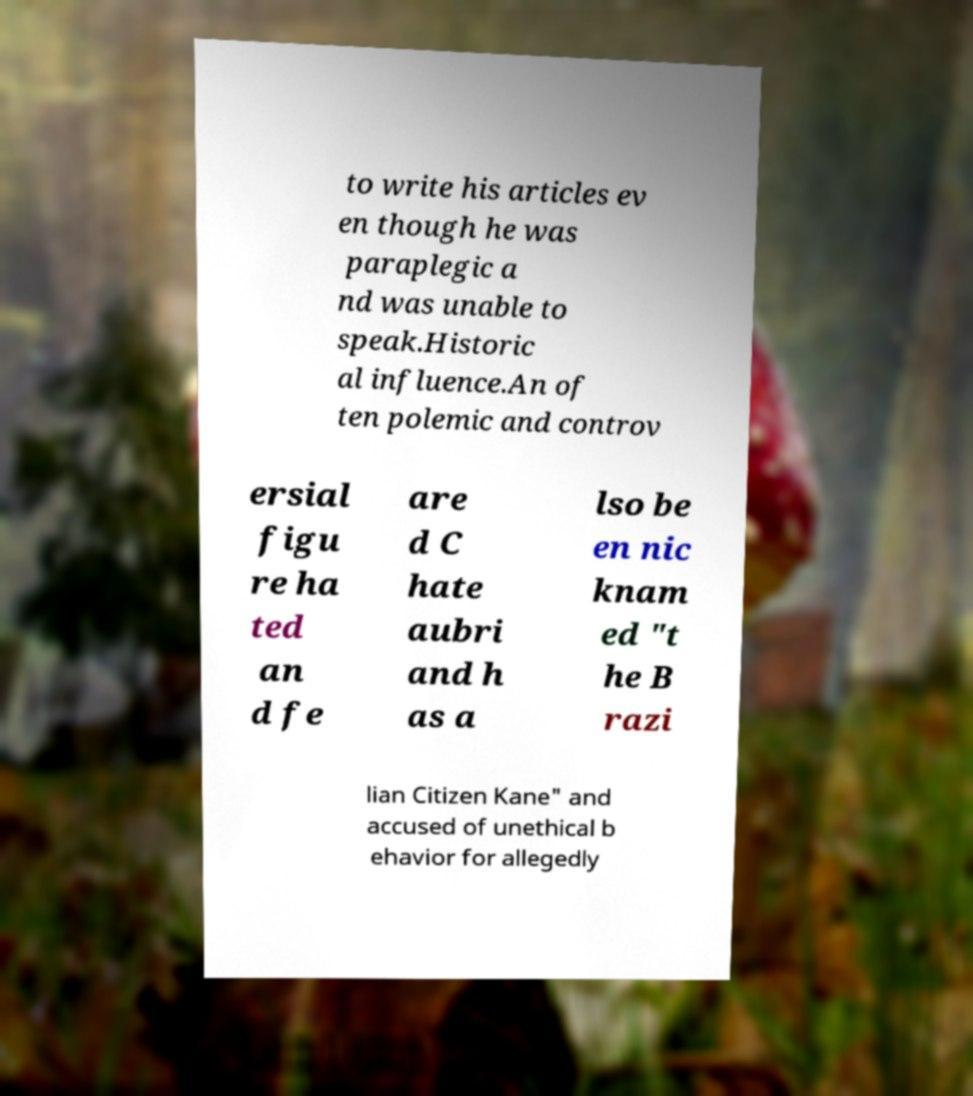There's text embedded in this image that I need extracted. Can you transcribe it verbatim? to write his articles ev en though he was paraplegic a nd was unable to speak.Historic al influence.An of ten polemic and controv ersial figu re ha ted an d fe are d C hate aubri and h as a lso be en nic knam ed "t he B razi lian Citizen Kane" and accused of unethical b ehavior for allegedly 